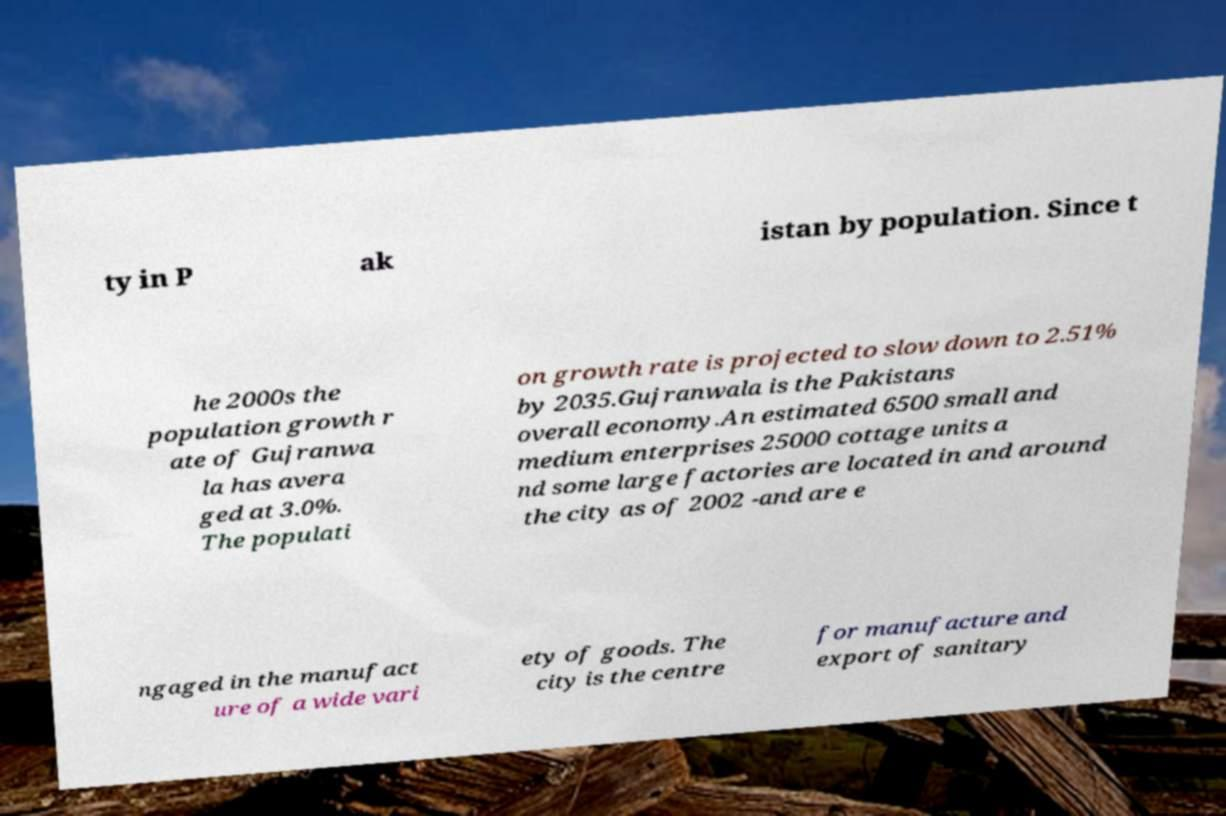Please identify and transcribe the text found in this image. ty in P ak istan by population. Since t he 2000s the population growth r ate of Gujranwa la has avera ged at 3.0%. The populati on growth rate is projected to slow down to 2.51% by 2035.Gujranwala is the Pakistans overall economy.An estimated 6500 small and medium enterprises 25000 cottage units a nd some large factories are located in and around the city as of 2002 -and are e ngaged in the manufact ure of a wide vari ety of goods. The city is the centre for manufacture and export of sanitary 